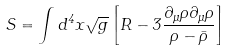Convert formula to latex. <formula><loc_0><loc_0><loc_500><loc_500>S = \int d ^ { 4 } x \sqrt { g } \left [ R - 3 \frac { \partial _ { \mu } \rho \partial _ { \mu } \rho } { \rho - \bar { \rho } } \right ]</formula> 